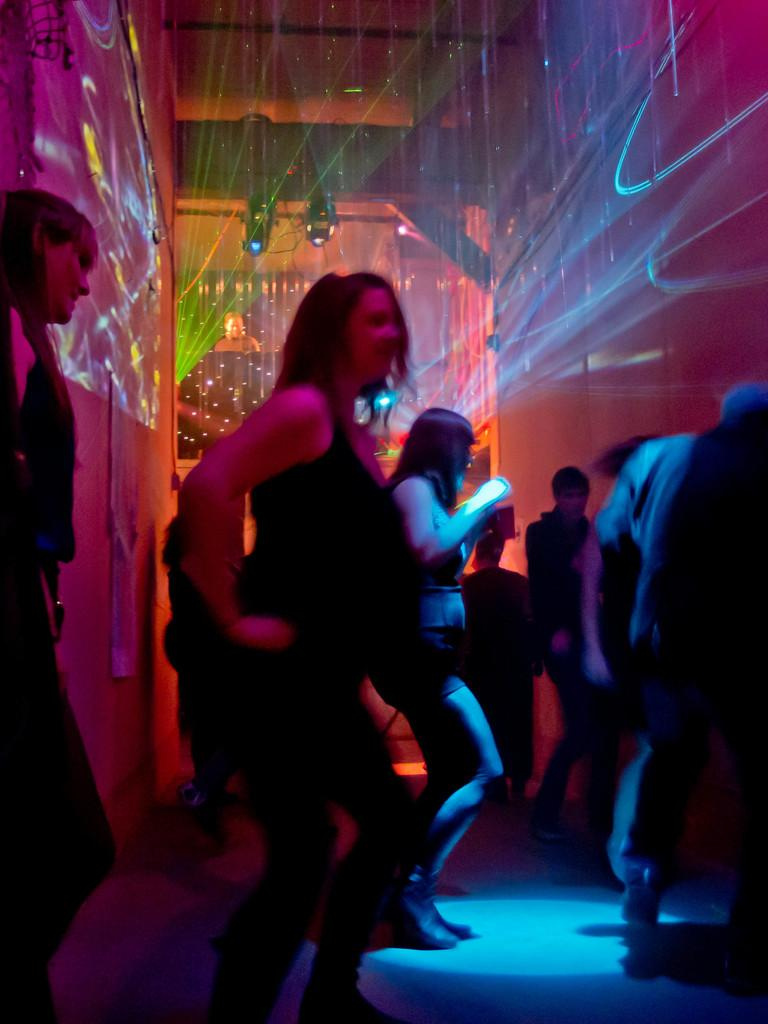What type of space is depicted in the image? The image is of a room. What activity is taking place in the room? There is a group of people dancing in the room. What can be seen at the top of the image? There are lights visible at the top of the image. What type of butter is being used by the dancers in the image? There is no butter present in the image, and the dancers are not using any butter. How many rings are visible on the fingers of the people dancing in the image? There is no mention of rings or any jewelry in the image, so we cannot determine the number of rings visible on the dancers' fingers. 